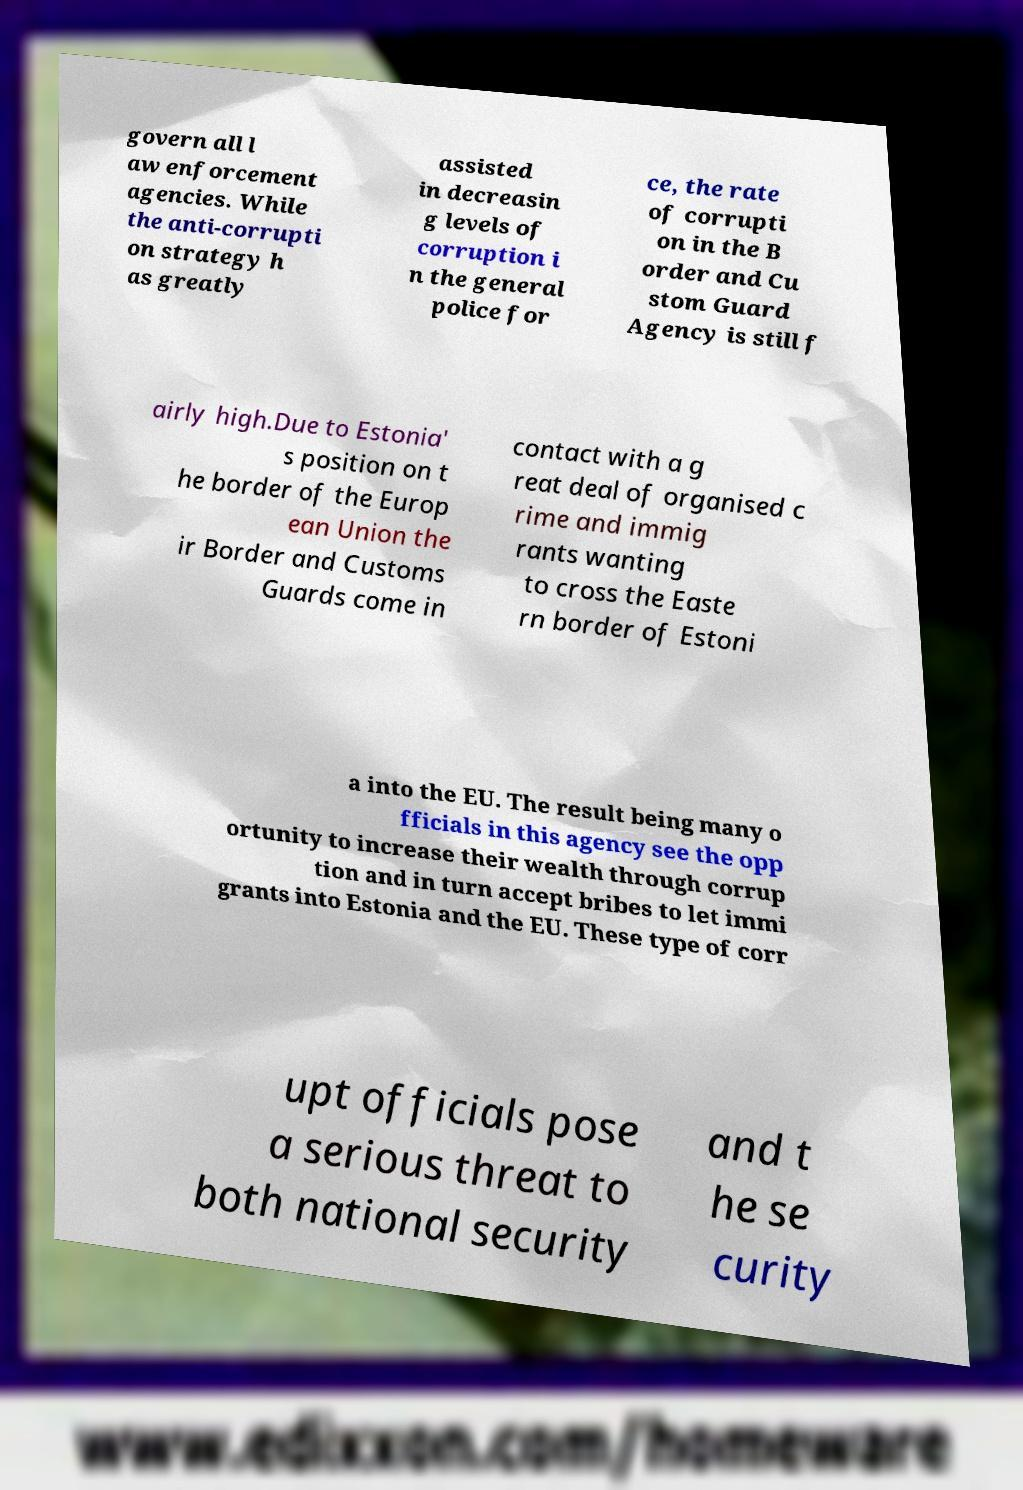Could you assist in decoding the text presented in this image and type it out clearly? govern all l aw enforcement agencies. While the anti-corrupti on strategy h as greatly assisted in decreasin g levels of corruption i n the general police for ce, the rate of corrupti on in the B order and Cu stom Guard Agency is still f airly high.Due to Estonia' s position on t he border of the Europ ean Union the ir Border and Customs Guards come in contact with a g reat deal of organised c rime and immig rants wanting to cross the Easte rn border of Estoni a into the EU. The result being many o fficials in this agency see the opp ortunity to increase their wealth through corrup tion and in turn accept bribes to let immi grants into Estonia and the EU. These type of corr upt officials pose a serious threat to both national security and t he se curity 